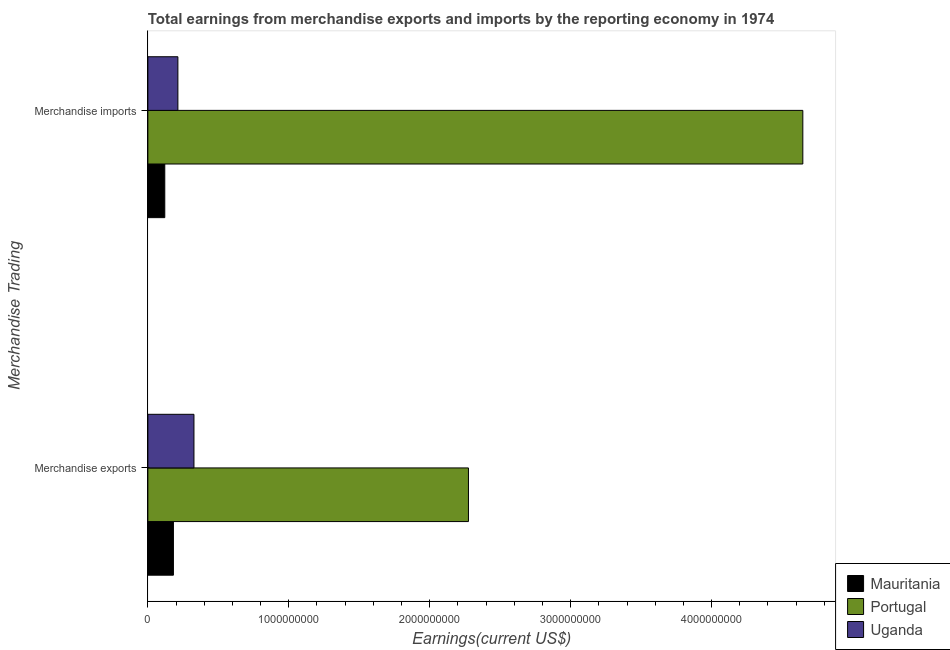How many different coloured bars are there?
Keep it short and to the point. 3. How many groups of bars are there?
Your response must be concise. 2. Are the number of bars on each tick of the Y-axis equal?
Provide a short and direct response. Yes. How many bars are there on the 1st tick from the bottom?
Make the answer very short. 3. What is the earnings from merchandise exports in Portugal?
Give a very brief answer. 2.27e+09. Across all countries, what is the maximum earnings from merchandise imports?
Give a very brief answer. 4.65e+09. Across all countries, what is the minimum earnings from merchandise imports?
Keep it short and to the point. 1.20e+08. In which country was the earnings from merchandise imports minimum?
Give a very brief answer. Mauritania. What is the total earnings from merchandise imports in the graph?
Your answer should be very brief. 4.98e+09. What is the difference between the earnings from merchandise exports in Uganda and that in Portugal?
Your answer should be compact. -1.95e+09. What is the difference between the earnings from merchandise imports in Uganda and the earnings from merchandise exports in Portugal?
Provide a short and direct response. -2.06e+09. What is the average earnings from merchandise exports per country?
Ensure brevity in your answer.  9.28e+08. What is the difference between the earnings from merchandise imports and earnings from merchandise exports in Uganda?
Give a very brief answer. -1.14e+08. What is the ratio of the earnings from merchandise exports in Uganda to that in Portugal?
Make the answer very short. 0.14. Is the earnings from merchandise imports in Mauritania less than that in Uganda?
Your response must be concise. Yes. In how many countries, is the earnings from merchandise imports greater than the average earnings from merchandise imports taken over all countries?
Your response must be concise. 1. What does the 1st bar from the bottom in Merchandise exports represents?
Your response must be concise. Mauritania. Are all the bars in the graph horizontal?
Keep it short and to the point. Yes. What is the difference between two consecutive major ticks on the X-axis?
Offer a terse response. 1.00e+09. What is the title of the graph?
Offer a very short reply. Total earnings from merchandise exports and imports by the reporting economy in 1974. Does "Upper middle income" appear as one of the legend labels in the graph?
Provide a short and direct response. No. What is the label or title of the X-axis?
Provide a short and direct response. Earnings(current US$). What is the label or title of the Y-axis?
Ensure brevity in your answer.  Merchandise Trading. What is the Earnings(current US$) in Mauritania in Merchandise exports?
Provide a short and direct response. 1.81e+08. What is the Earnings(current US$) in Portugal in Merchandise exports?
Give a very brief answer. 2.27e+09. What is the Earnings(current US$) in Uganda in Merchandise exports?
Provide a short and direct response. 3.27e+08. What is the Earnings(current US$) in Mauritania in Merchandise imports?
Give a very brief answer. 1.20e+08. What is the Earnings(current US$) of Portugal in Merchandise imports?
Ensure brevity in your answer.  4.65e+09. What is the Earnings(current US$) of Uganda in Merchandise imports?
Ensure brevity in your answer.  2.13e+08. Across all Merchandise Trading, what is the maximum Earnings(current US$) of Mauritania?
Your response must be concise. 1.81e+08. Across all Merchandise Trading, what is the maximum Earnings(current US$) of Portugal?
Provide a short and direct response. 4.65e+09. Across all Merchandise Trading, what is the maximum Earnings(current US$) in Uganda?
Provide a short and direct response. 3.27e+08. Across all Merchandise Trading, what is the minimum Earnings(current US$) in Mauritania?
Provide a succinct answer. 1.20e+08. Across all Merchandise Trading, what is the minimum Earnings(current US$) in Portugal?
Provide a succinct answer. 2.27e+09. Across all Merchandise Trading, what is the minimum Earnings(current US$) in Uganda?
Keep it short and to the point. 2.13e+08. What is the total Earnings(current US$) of Mauritania in the graph?
Give a very brief answer. 3.01e+08. What is the total Earnings(current US$) in Portugal in the graph?
Make the answer very short. 6.92e+09. What is the total Earnings(current US$) of Uganda in the graph?
Your answer should be very brief. 5.40e+08. What is the difference between the Earnings(current US$) in Mauritania in Merchandise exports and that in Merchandise imports?
Provide a succinct answer. 6.13e+07. What is the difference between the Earnings(current US$) of Portugal in Merchandise exports and that in Merchandise imports?
Give a very brief answer. -2.37e+09. What is the difference between the Earnings(current US$) in Uganda in Merchandise exports and that in Merchandise imports?
Give a very brief answer. 1.14e+08. What is the difference between the Earnings(current US$) in Mauritania in Merchandise exports and the Earnings(current US$) in Portugal in Merchandise imports?
Ensure brevity in your answer.  -4.47e+09. What is the difference between the Earnings(current US$) of Mauritania in Merchandise exports and the Earnings(current US$) of Uganda in Merchandise imports?
Offer a terse response. -3.17e+07. What is the difference between the Earnings(current US$) in Portugal in Merchandise exports and the Earnings(current US$) in Uganda in Merchandise imports?
Offer a terse response. 2.06e+09. What is the average Earnings(current US$) of Mauritania per Merchandise Trading?
Your answer should be very brief. 1.51e+08. What is the average Earnings(current US$) of Portugal per Merchandise Trading?
Ensure brevity in your answer.  3.46e+09. What is the average Earnings(current US$) in Uganda per Merchandise Trading?
Your answer should be very brief. 2.70e+08. What is the difference between the Earnings(current US$) in Mauritania and Earnings(current US$) in Portugal in Merchandise exports?
Offer a terse response. -2.09e+09. What is the difference between the Earnings(current US$) in Mauritania and Earnings(current US$) in Uganda in Merchandise exports?
Give a very brief answer. -1.46e+08. What is the difference between the Earnings(current US$) of Portugal and Earnings(current US$) of Uganda in Merchandise exports?
Offer a terse response. 1.95e+09. What is the difference between the Earnings(current US$) of Mauritania and Earnings(current US$) of Portugal in Merchandise imports?
Your response must be concise. -4.53e+09. What is the difference between the Earnings(current US$) in Mauritania and Earnings(current US$) in Uganda in Merchandise imports?
Provide a succinct answer. -9.30e+07. What is the difference between the Earnings(current US$) in Portugal and Earnings(current US$) in Uganda in Merchandise imports?
Your answer should be very brief. 4.43e+09. What is the ratio of the Earnings(current US$) of Mauritania in Merchandise exports to that in Merchandise imports?
Provide a succinct answer. 1.51. What is the ratio of the Earnings(current US$) in Portugal in Merchandise exports to that in Merchandise imports?
Provide a succinct answer. 0.49. What is the ratio of the Earnings(current US$) of Uganda in Merchandise exports to that in Merchandise imports?
Provide a short and direct response. 1.53. What is the difference between the highest and the second highest Earnings(current US$) in Mauritania?
Provide a succinct answer. 6.13e+07. What is the difference between the highest and the second highest Earnings(current US$) of Portugal?
Your answer should be compact. 2.37e+09. What is the difference between the highest and the second highest Earnings(current US$) in Uganda?
Your answer should be compact. 1.14e+08. What is the difference between the highest and the lowest Earnings(current US$) of Mauritania?
Your answer should be very brief. 6.13e+07. What is the difference between the highest and the lowest Earnings(current US$) of Portugal?
Provide a succinct answer. 2.37e+09. What is the difference between the highest and the lowest Earnings(current US$) in Uganda?
Provide a succinct answer. 1.14e+08. 